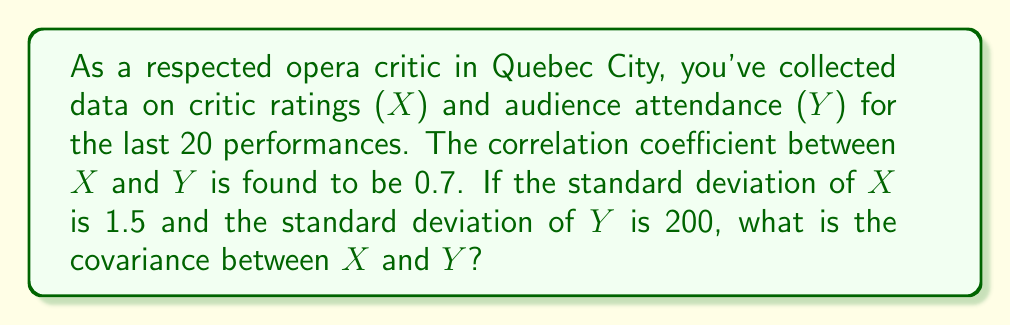Help me with this question. Let's approach this step-by-step:

1) The correlation coefficient ($\rho$) is defined as:

   $$\rho = \frac{Cov(X,Y)}{\sigma_X \sigma_Y}$$

   where $Cov(X,Y)$ is the covariance between X and Y, and $\sigma_X$ and $\sigma_Y$ are the standard deviations of X and Y respectively.

2) We are given:
   - $\rho = 0.7$
   - $\sigma_X = 1.5$
   - $\sigma_Y = 200$

3) Substituting these values into the correlation coefficient formula:

   $$0.7 = \frac{Cov(X,Y)}{1.5 \cdot 200}$$

4) Now, let's solve for $Cov(X,Y)$:

   $$Cov(X,Y) = 0.7 \cdot 1.5 \cdot 200$$

5) Calculate:

   $$Cov(X,Y) = 0.7 \cdot 300 = 210$$

Therefore, the covariance between critic ratings (X) and audience attendance (Y) is 210.
Answer: 210 